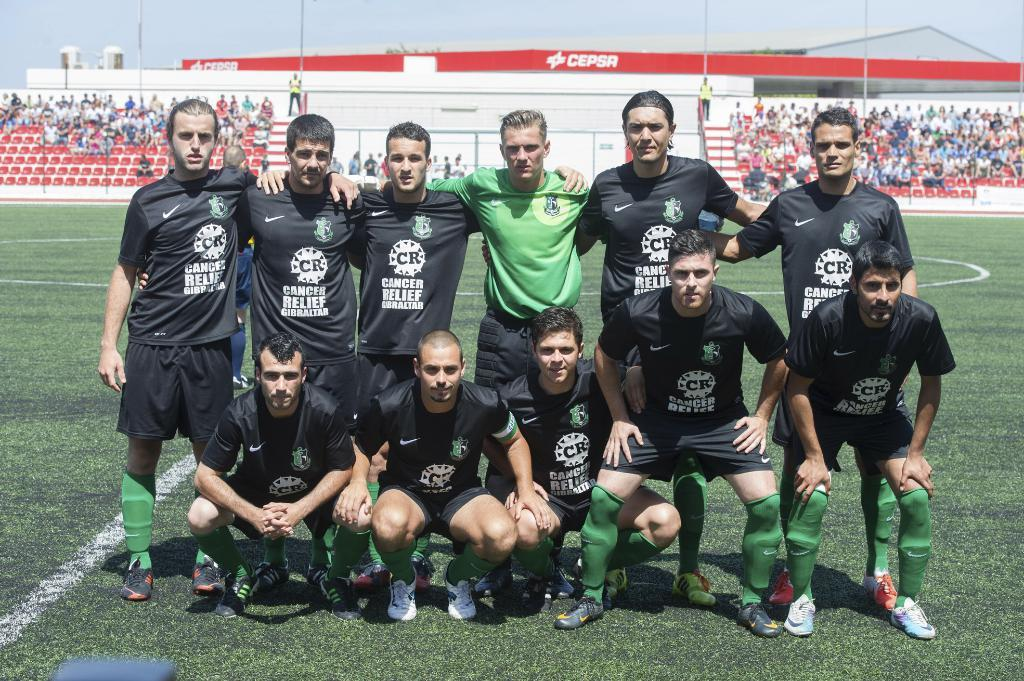<image>
Offer a succinct explanation of the picture presented. The shirts the people are wearing are for a Cancer Relief event 